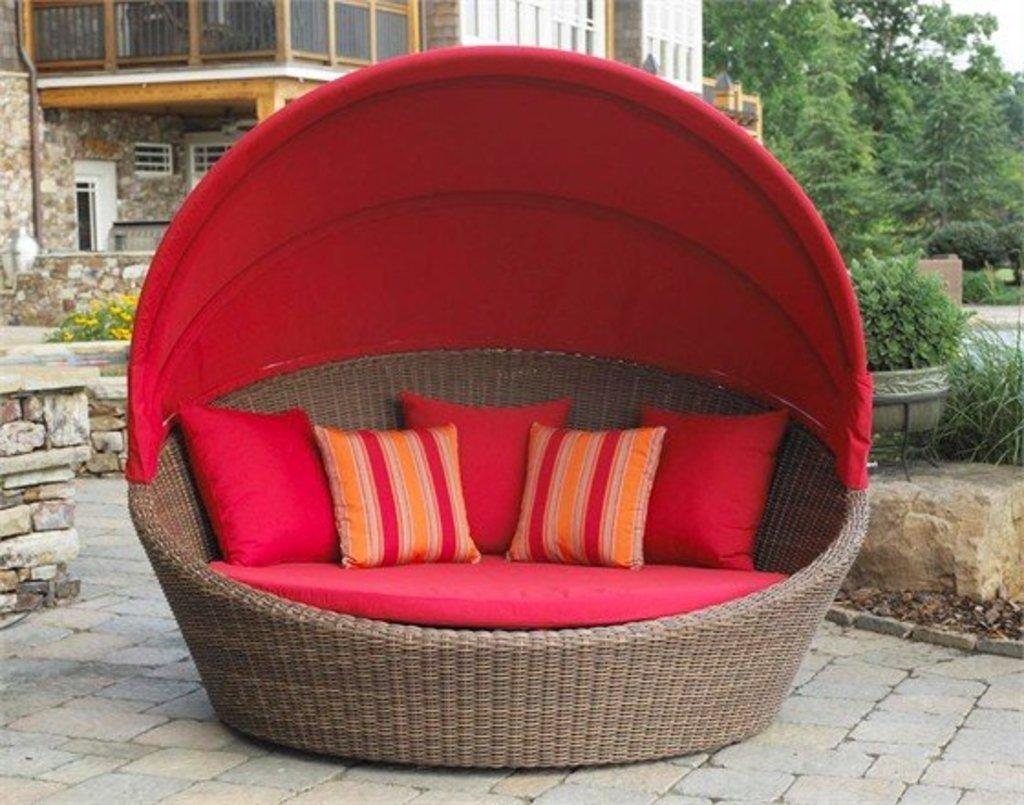What is the main object in the center of the image? There is an outdoor wicker daybed in the center of the image. What is placed on the daybed? There are pillows on the daybed. What can be seen in the background of the image? Buildings, fences, trees, plants, grass, and flowers are visible in the background of the image. Are there any pots present in the image? Yes, pots are present in the background of the image. What type of ear is visible on the daybed in the image? There are no ears visible on the daybed in the image. What kind of bait is being used to catch fish in the image? There is no fishing or bait present in the image; it features an outdoor wicker daybed with pillows and a background containing various elements. 